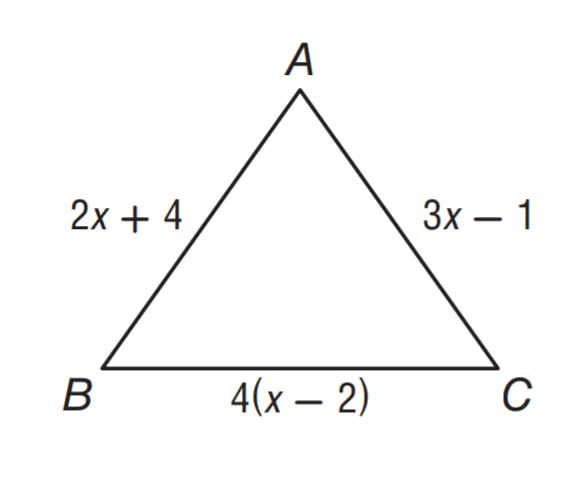Question: \triangle A B C is an isosceles triangle with base B C. What is the perimeter of the triangle?
Choices:
A. 5
B. 12
C. 14
D. 40
Answer with the letter. Answer: D 